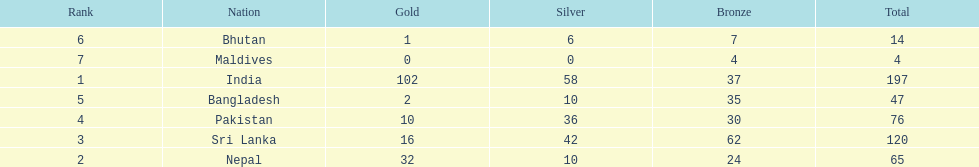Name a country listed in the table, other than india? Nepal. 